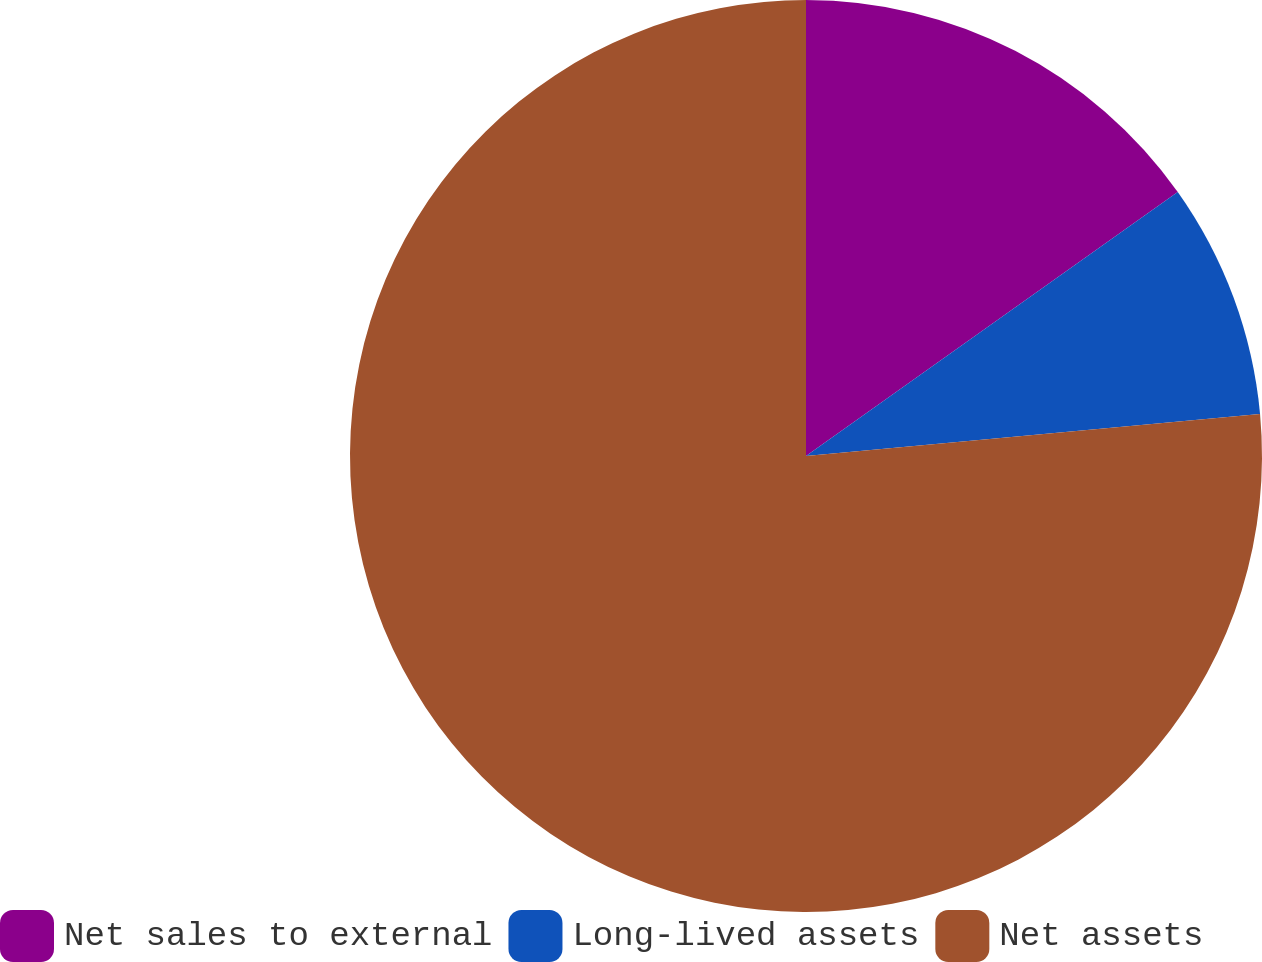<chart> <loc_0><loc_0><loc_500><loc_500><pie_chart><fcel>Net sales to external<fcel>Long-lived assets<fcel>Net assets<nl><fcel>15.17%<fcel>8.36%<fcel>76.47%<nl></chart> 